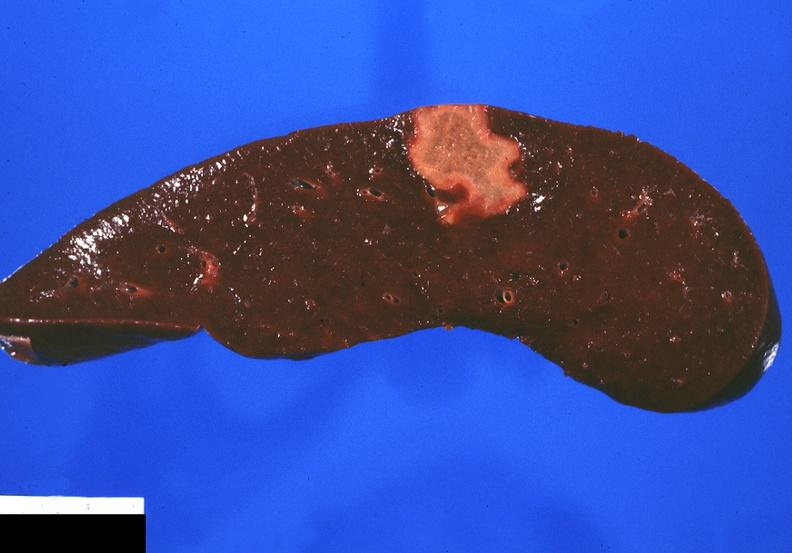does this image show splenic infarct?
Answer the question using a single word or phrase. Yes 